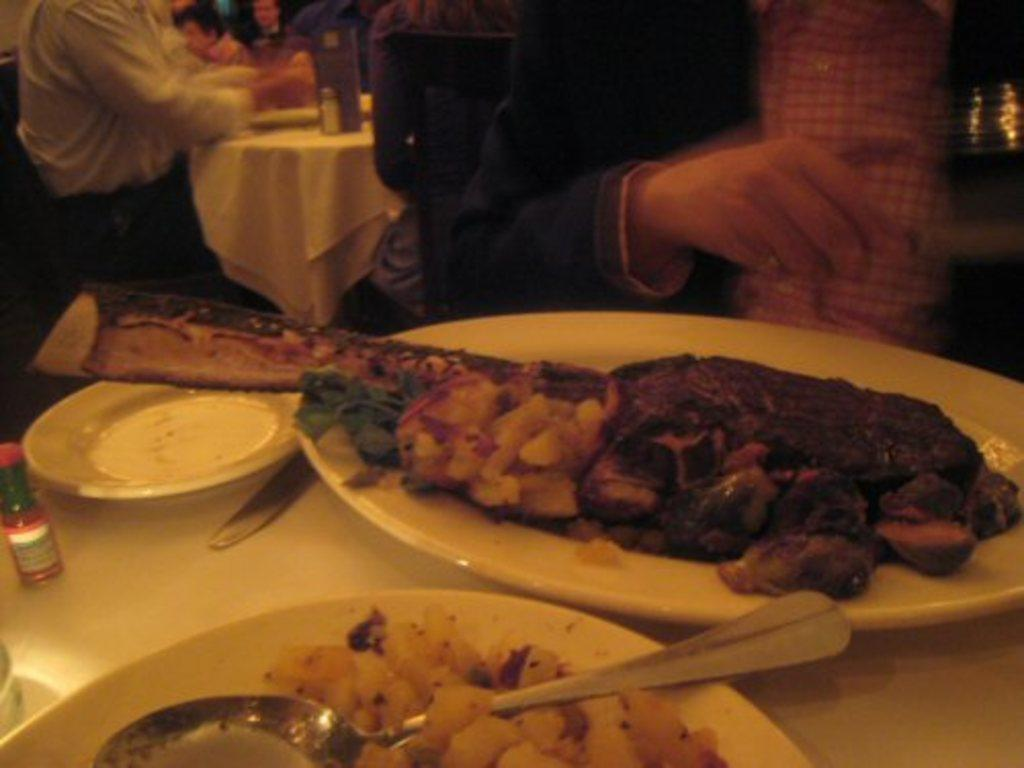What are the people in the image doing? The people in the image are sitting on chairs. What can be seen on the table in the image? Spoons and a bottle are present on the table in the image. What is in the foreground of the image? There are plates containing food in the foreground of the image. Can you see any pig or fowl in the image? No, there are no pigs or fowl present in the image. What color are the toes of the people sitting on chairs? There is no information about the color of the people's toes in the image, as the focus is on their sitting position and the objects on the table. 